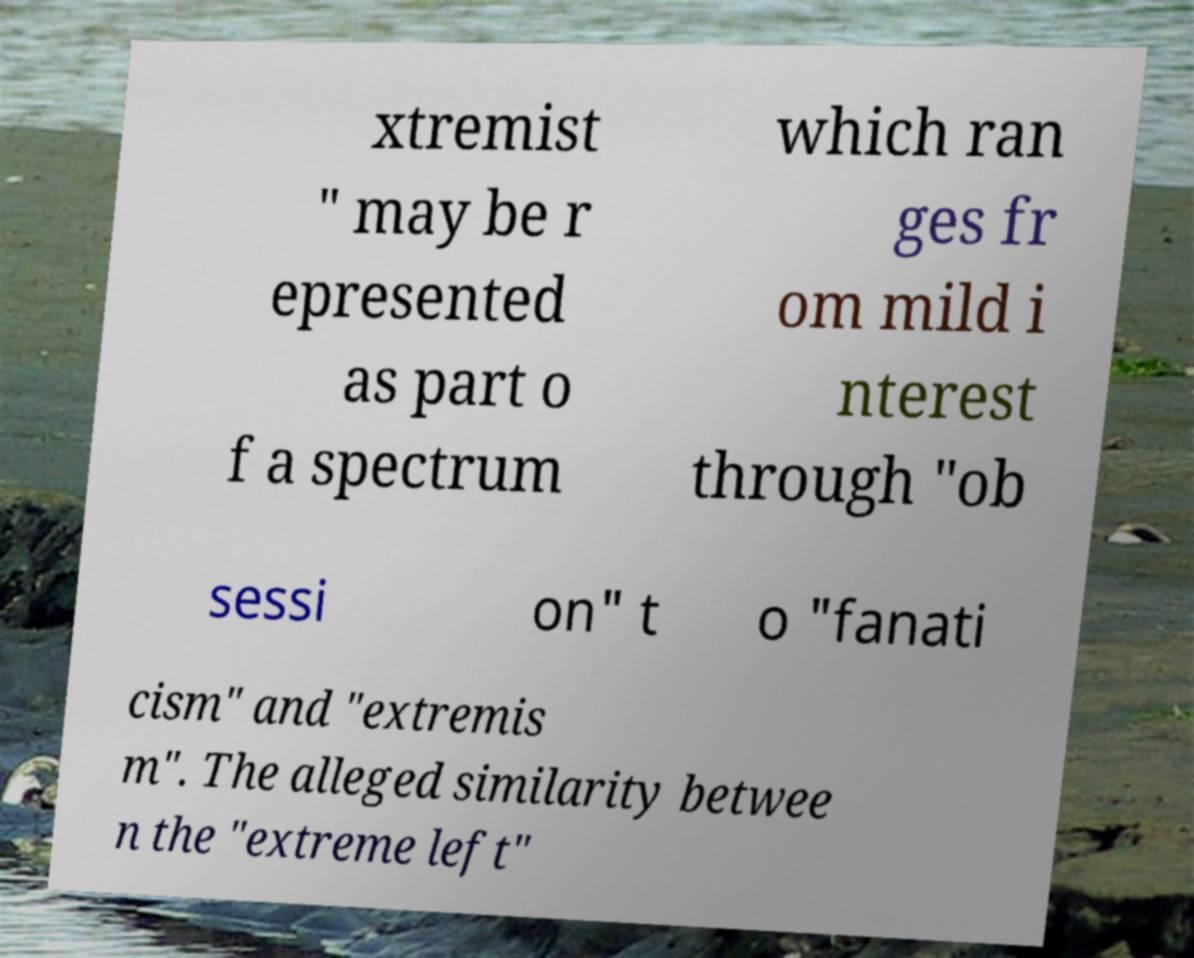For documentation purposes, I need the text within this image transcribed. Could you provide that? xtremist " may be r epresented as part o f a spectrum which ran ges fr om mild i nterest through "ob sessi on" t o "fanati cism" and "extremis m". The alleged similarity betwee n the "extreme left" 